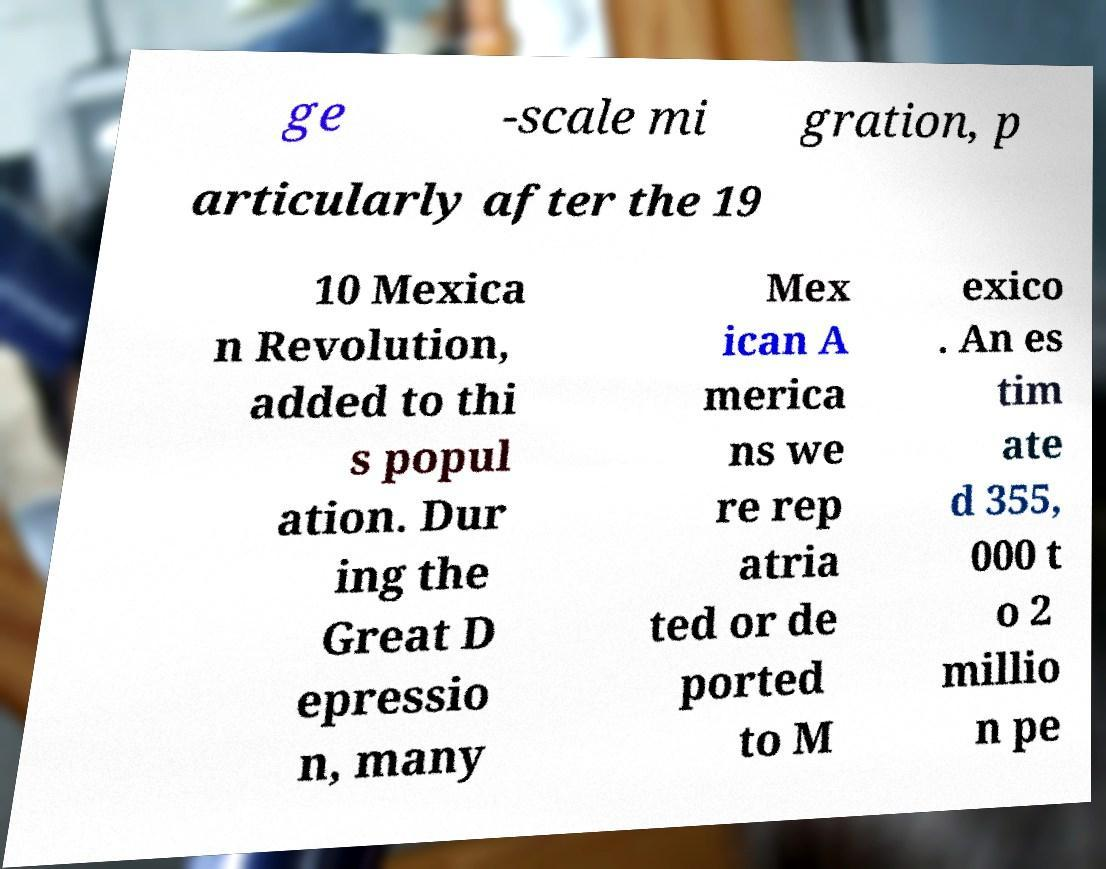Could you assist in decoding the text presented in this image and type it out clearly? ge -scale mi gration, p articularly after the 19 10 Mexica n Revolution, added to thi s popul ation. Dur ing the Great D epressio n, many Mex ican A merica ns we re rep atria ted or de ported to M exico . An es tim ate d 355, 000 t o 2 millio n pe 